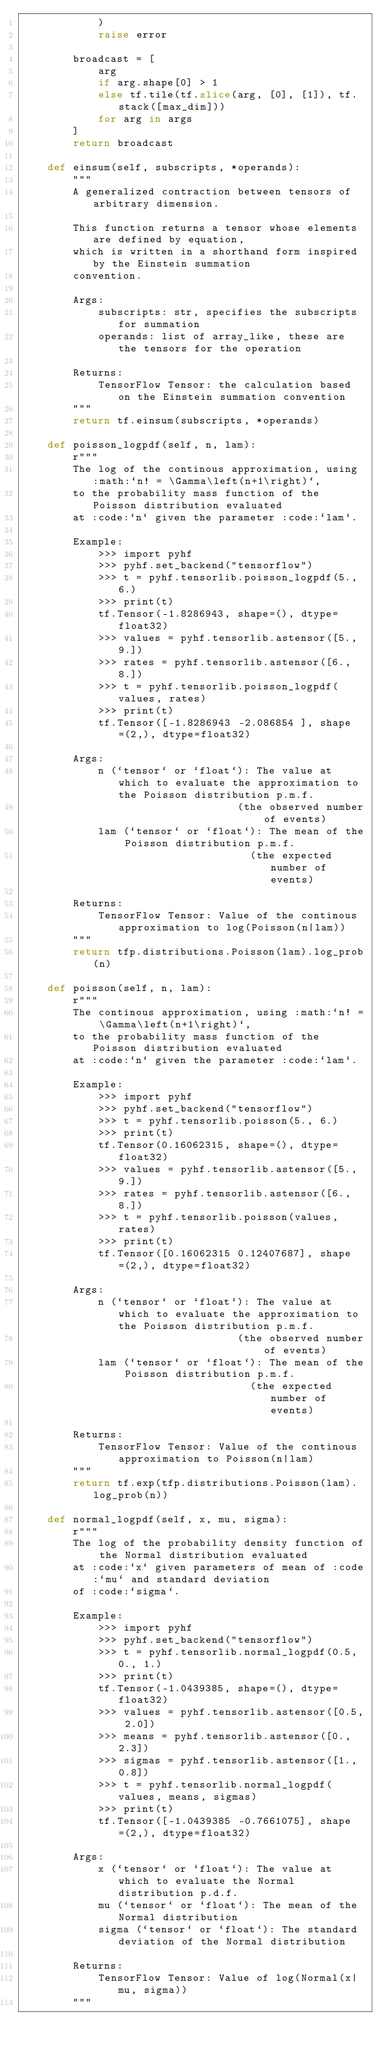<code> <loc_0><loc_0><loc_500><loc_500><_Python_>            )
            raise error

        broadcast = [
            arg
            if arg.shape[0] > 1
            else tf.tile(tf.slice(arg, [0], [1]), tf.stack([max_dim]))
            for arg in args
        ]
        return broadcast

    def einsum(self, subscripts, *operands):
        """
        A generalized contraction between tensors of arbitrary dimension.

        This function returns a tensor whose elements are defined by equation,
        which is written in a shorthand form inspired by the Einstein summation
        convention.

        Args:
            subscripts: str, specifies the subscripts for summation
            operands: list of array_like, these are the tensors for the operation

        Returns:
            TensorFlow Tensor: the calculation based on the Einstein summation convention
        """
        return tf.einsum(subscripts, *operands)

    def poisson_logpdf(self, n, lam):
        r"""
        The log of the continous approximation, using :math:`n! = \Gamma\left(n+1\right)`,
        to the probability mass function of the Poisson distribution evaluated
        at :code:`n` given the parameter :code:`lam`.

        Example:
            >>> import pyhf
            >>> pyhf.set_backend("tensorflow")
            >>> t = pyhf.tensorlib.poisson_logpdf(5., 6.)
            >>> print(t)
            tf.Tensor(-1.8286943, shape=(), dtype=float32)
            >>> values = pyhf.tensorlib.astensor([5., 9.])
            >>> rates = pyhf.tensorlib.astensor([6., 8.])
            >>> t = pyhf.tensorlib.poisson_logpdf(values, rates)
            >>> print(t)
            tf.Tensor([-1.8286943 -2.086854 ], shape=(2,), dtype=float32)

        Args:
            n (`tensor` or `float`): The value at which to evaluate the approximation to the Poisson distribution p.m.f.
                                  (the observed number of events)
            lam (`tensor` or `float`): The mean of the Poisson distribution p.m.f.
                                    (the expected number of events)

        Returns:
            TensorFlow Tensor: Value of the continous approximation to log(Poisson(n|lam))
        """
        return tfp.distributions.Poisson(lam).log_prob(n)

    def poisson(self, n, lam):
        r"""
        The continous approximation, using :math:`n! = \Gamma\left(n+1\right)`,
        to the probability mass function of the Poisson distribution evaluated
        at :code:`n` given the parameter :code:`lam`.

        Example:
            >>> import pyhf
            >>> pyhf.set_backend("tensorflow")
            >>> t = pyhf.tensorlib.poisson(5., 6.)
            >>> print(t)
            tf.Tensor(0.16062315, shape=(), dtype=float32)
            >>> values = pyhf.tensorlib.astensor([5., 9.])
            >>> rates = pyhf.tensorlib.astensor([6., 8.])
            >>> t = pyhf.tensorlib.poisson(values, rates)
            >>> print(t)
            tf.Tensor([0.16062315 0.12407687], shape=(2,), dtype=float32)

        Args:
            n (`tensor` or `float`): The value at which to evaluate the approximation to the Poisson distribution p.m.f.
                                  (the observed number of events)
            lam (`tensor` or `float`): The mean of the Poisson distribution p.m.f.
                                    (the expected number of events)

        Returns:
            TensorFlow Tensor: Value of the continous approximation to Poisson(n|lam)
        """
        return tf.exp(tfp.distributions.Poisson(lam).log_prob(n))

    def normal_logpdf(self, x, mu, sigma):
        r"""
        The log of the probability density function of the Normal distribution evaluated
        at :code:`x` given parameters of mean of :code:`mu` and standard deviation
        of :code:`sigma`.

        Example:
            >>> import pyhf
            >>> pyhf.set_backend("tensorflow")
            >>> t = pyhf.tensorlib.normal_logpdf(0.5, 0., 1.)
            >>> print(t)
            tf.Tensor(-1.0439385, shape=(), dtype=float32)
            >>> values = pyhf.tensorlib.astensor([0.5, 2.0])
            >>> means = pyhf.tensorlib.astensor([0., 2.3])
            >>> sigmas = pyhf.tensorlib.astensor([1., 0.8])
            >>> t = pyhf.tensorlib.normal_logpdf(values, means, sigmas)
            >>> print(t)
            tf.Tensor([-1.0439385 -0.7661075], shape=(2,), dtype=float32)

        Args:
            x (`tensor` or `float`): The value at which to evaluate the Normal distribution p.d.f.
            mu (`tensor` or `float`): The mean of the Normal distribution
            sigma (`tensor` or `float`): The standard deviation of the Normal distribution

        Returns:
            TensorFlow Tensor: Value of log(Normal(x|mu, sigma))
        """</code> 